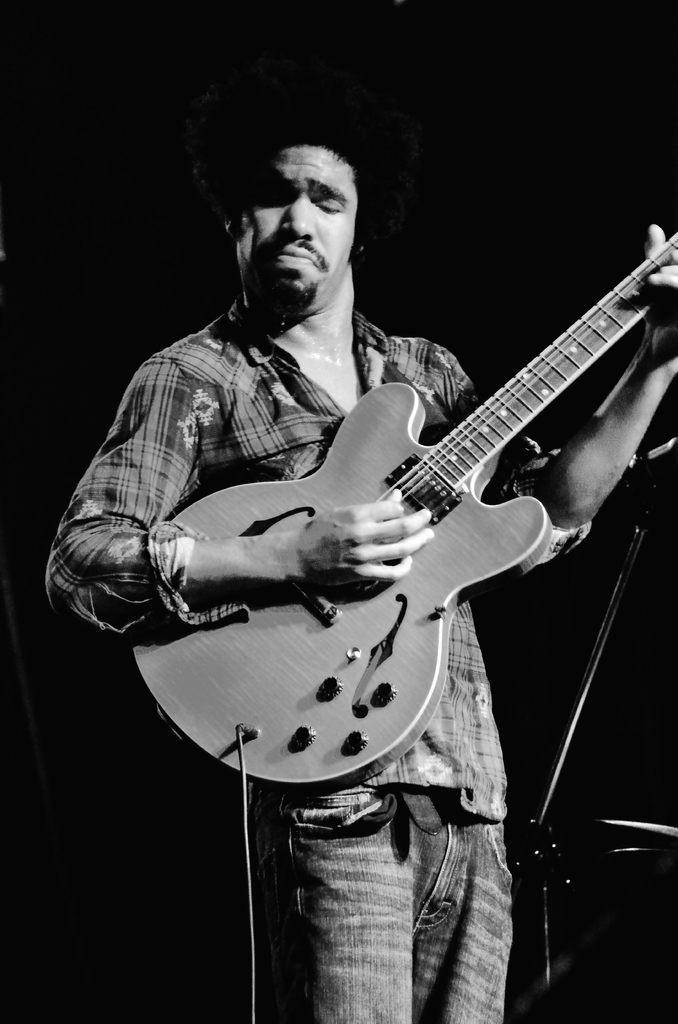Can you describe this image briefly? In this picture there is a man holding a guitar and playing it. 